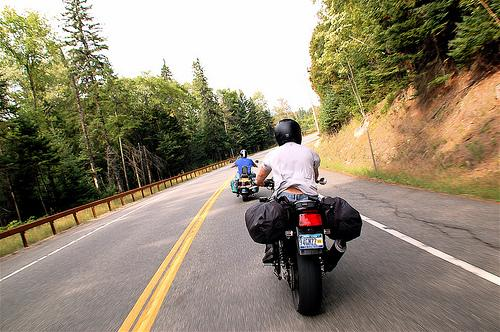Mention the significant features of the motorcycles. The motorcycles have black rubber tires, red taillights, and blue and white license plates. One of them has black saddlebags. What is the condition of the sky in the image? The sky is grey and cloudy with thick grey clouds. Explain the landscape alongside the road. There are green trees and grass along the road on one side, with a brown guardrail and a small brown fence on the other side. What is the main action taking place in the picture? Two people are riding motorcycles on the road. What kind of road does the image depict, and what is its setting? The image depicts a curved gray road through a wooded area with road markings, trees, and guardrails. Tell me about the colors and objects of the two rider's clothing. One rider is wearing a blue short sleeve shirt, and the other is wearing a grey short sleeve shirt. They both wear black helmets. How many motorbike riders are there, and what is unique about their positioning? There are two motorbike riders, one wearing a blue shirt is ahead of the other wearing a white shirt. Enumerate the items associated with the road that stand out. The double yellow line, white line, dark cracks, road's dark grey color, and the presence of motorcycles with riders. Describe the road's appearance and markings. The road is dark grey with double yellow lines in the center and a white line near the bikes. It has dark cracks along its side. Provide a brief narrative of the scene in this image. Two men are riding motorbikes along a dark grey, curved road with double yellow lines and a white line. There are green trees on one side and a brown guardrail on the other. What type of fence is present in the image? brown guardrail What color are the trees in the background assumed to be? green How many motorcycles are in the image? two Which description best suits the road in the image: (a) straight and wide (b) curved and narrow (c) flat and smooth (d) bumpy and uneven? (b) curved and narrow Write a brief description of the road conditions in the image. The road is dark grey, curved, and narrow with a double yellow line and a white line marking the path. There are cracks along the side and a brown guardrail is present. Create a caption for the image using a poetic language style. Whispering trees dance beside the winding grey road, as two riders with heartbeats in their helmets traverse the serpentine path, guided by lines of yellow and white. Are the motorcycles parked on the side of the road? The motorcycles are being ridden on the road, not parked on the side of the road. Which direction are the motorbike riders going? Cannot determine the direction as the image is static. Is the road a light shade of grey with no markings? The road is actually dark grey with a double yellow line and a white line, not light grey with no markings. What type of vehicles are present in the image? motorcycles Are there only cars on the road? There are actually motorbike riders on the road, not cars. Are the riders wearing green shirts? The riders are wearing a grey short sleeve shirt and a blue short sleeve shirt, not green shirts. Is there a tall white fence along the road? There is a small brown fence along the road, not a tall white fence. Describe the emotions of the motorcycle riders. Cannot determine the emotions as their faces are not visible. What is the color of the taillight on the bike? red What object is on the rider's head in the image? helmet Explain the potential danger in the image. The road is narrow and curvy, which could be dangerous for the motorcycle riders. What surface is the road made of? dark grey asphalt What color are the clouds in the sky? grey What objects are attached on the back of the motorcycle in the image? black saddlebags Is the sky bright blue and sunny? The sky is actually grey and cloudy, not bright blue and sunny. Describe the location of the motorcycles on the road. The motorcycles are between the double yellow line and the white line on the road. Identify the colors of the two riders' shirts. One is wearing a blue shirt, and the other is wearing a grey shirt. Translate the scene in the image into a creative story. On a grey, cloudy day, two friends took their motorcycles on a thrilling adventure through a winding, narrow road surrounded by lush green trees and a sloping dirt hill. The double yellow and white lines marked the path, guiding their way as they navigated the curves with excitement. Identify the line pattern in the middle of the road. double yellow line What color is the helmet of the rider wearing a blue shirt? black 